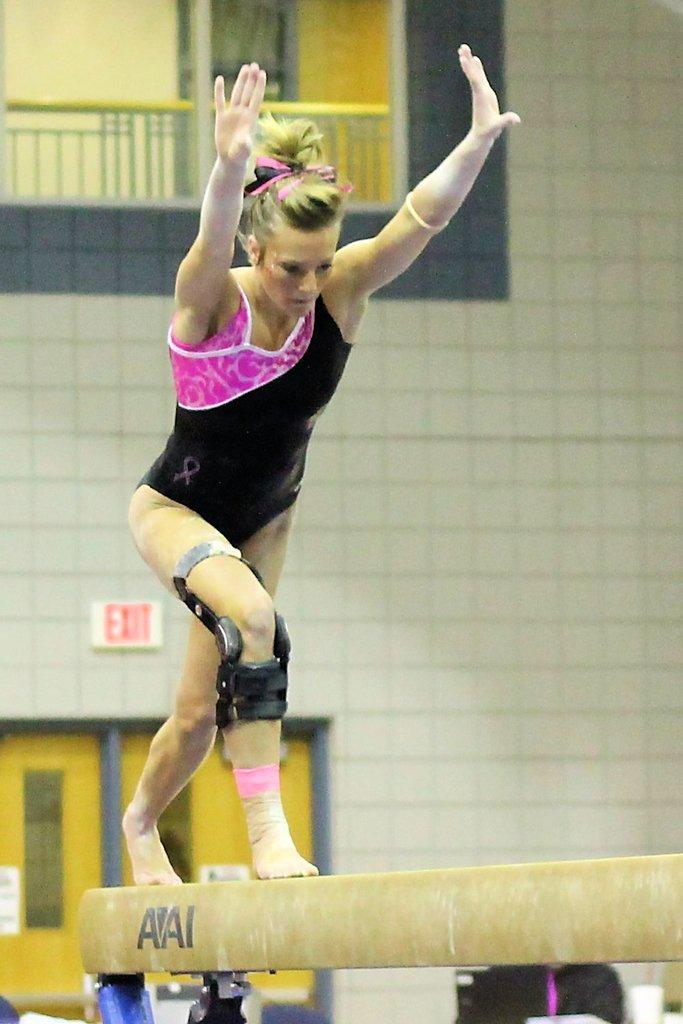What is the main subject of the image? There is a gymnast in the image. What is the gymnast doing in the image? The gymnast is raising her hands and standing on a pole. What can be seen in the background of the image? There is a wall with an exit door in the background. What is at the top of the image? There is an iron railing at the top of the image. What type of pump is being used by the gymnast in the image? There is no pump present in the image; the gymnast is standing on a pole. How does the gymnast plan to neutralize the poison in the image? There is no mention of poison in the image; the gymnast is performing a gymnastics routine. 